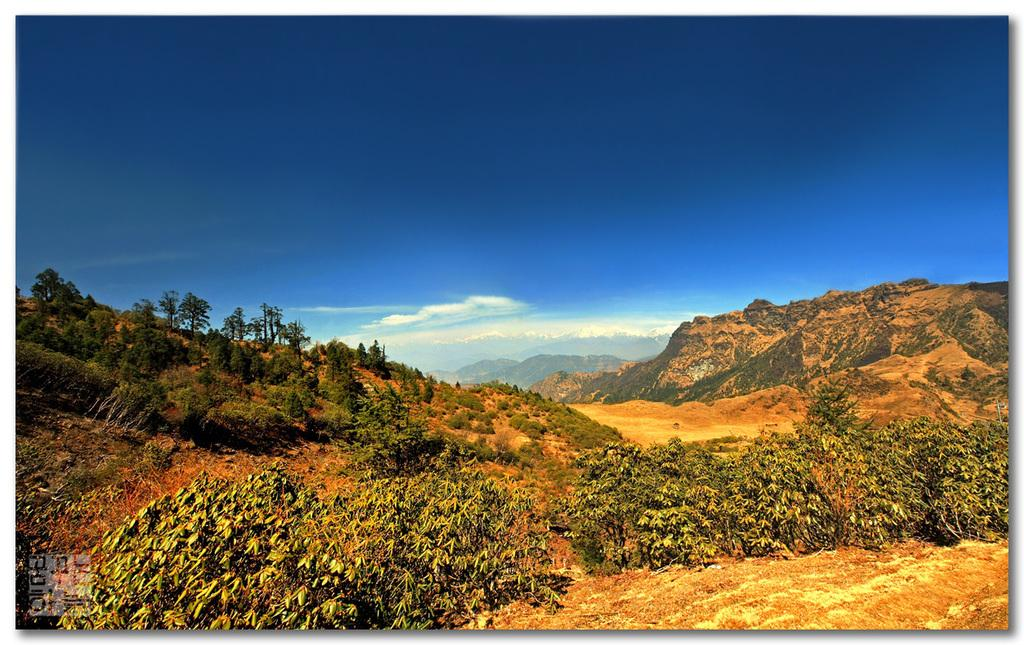What type of vegetation can be seen in the image? There are trees and plants in the image. What geographical feature is located in the middle of the image? There are hills in the middle of the image. What can be seen in the sky in the image? There are clouds in the sky. What type of twig is the father holding in the image? There is no father or twig present in the image. Is the poison visible in the image? There is no poison present in the image. 